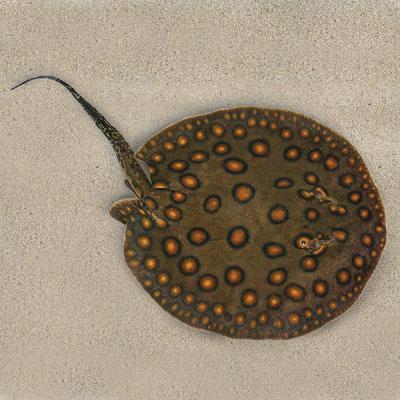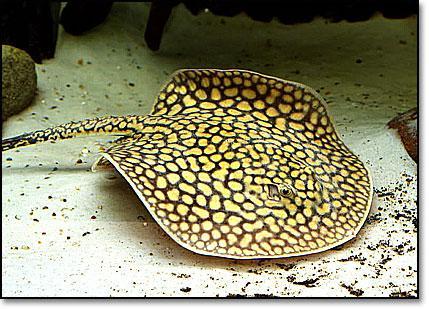The first image is the image on the left, the second image is the image on the right. Given the left and right images, does the statement "there are 3 stingrays in the image pair" hold true? Answer yes or no. No. The first image is the image on the left, the second image is the image on the right. Analyze the images presented: Is the assertion "No more than 2 animals in any of the pictures" valid? Answer yes or no. Yes. 